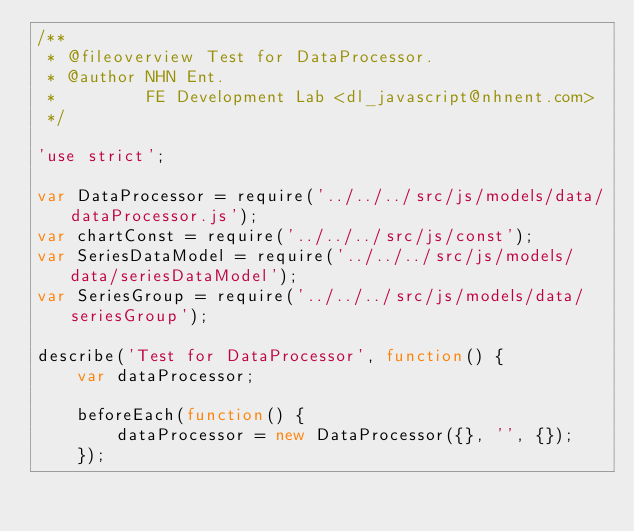Convert code to text. <code><loc_0><loc_0><loc_500><loc_500><_JavaScript_>/**
 * @fileoverview Test for DataProcessor.
 * @author NHN Ent.
 *         FE Development Lab <dl_javascript@nhnent.com>
 */

'use strict';

var DataProcessor = require('../../../src/js/models/data/dataProcessor.js');
var chartConst = require('../../../src/js/const');
var SeriesDataModel = require('../../../src/js/models/data/seriesDataModel');
var SeriesGroup = require('../../../src/js/models/data/seriesGroup');

describe('Test for DataProcessor', function() {
    var dataProcessor;

    beforeEach(function() {
        dataProcessor = new DataProcessor({}, '', {});
    });
</code> 